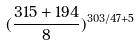<formula> <loc_0><loc_0><loc_500><loc_500>( \frac { 3 1 5 + 1 9 4 } { 8 } ) ^ { 3 0 3 / 4 7 + 5 }</formula> 